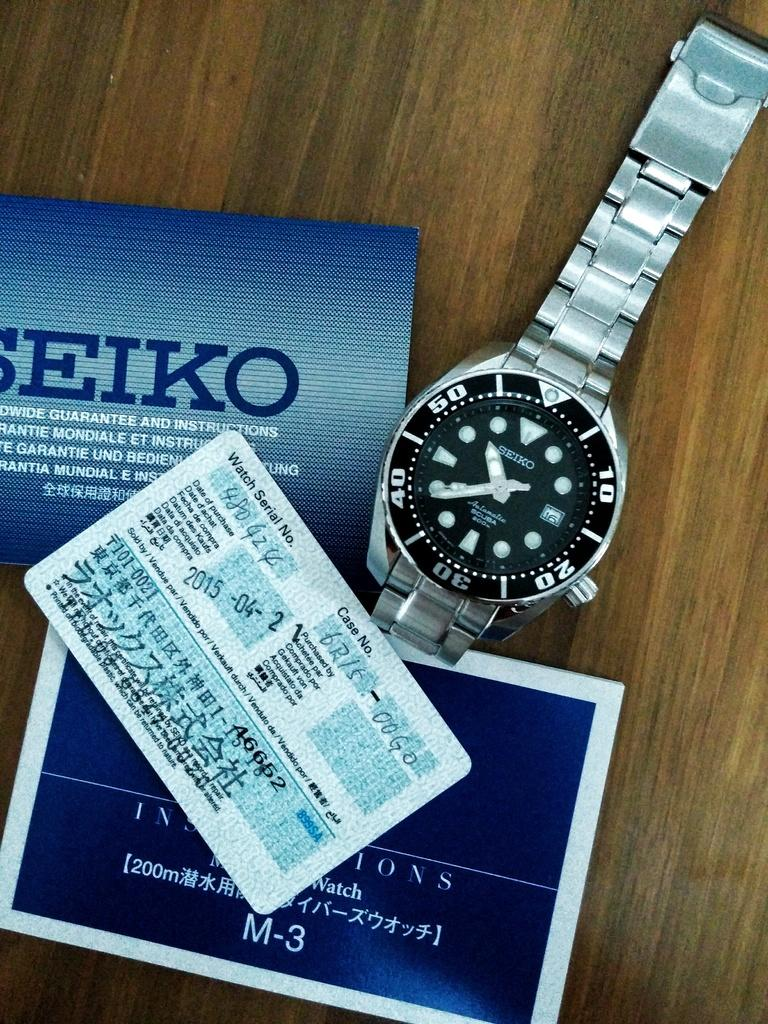<image>
Summarize the visual content of the image. A Seiko watch is displayed with the paperwork that it came with. 